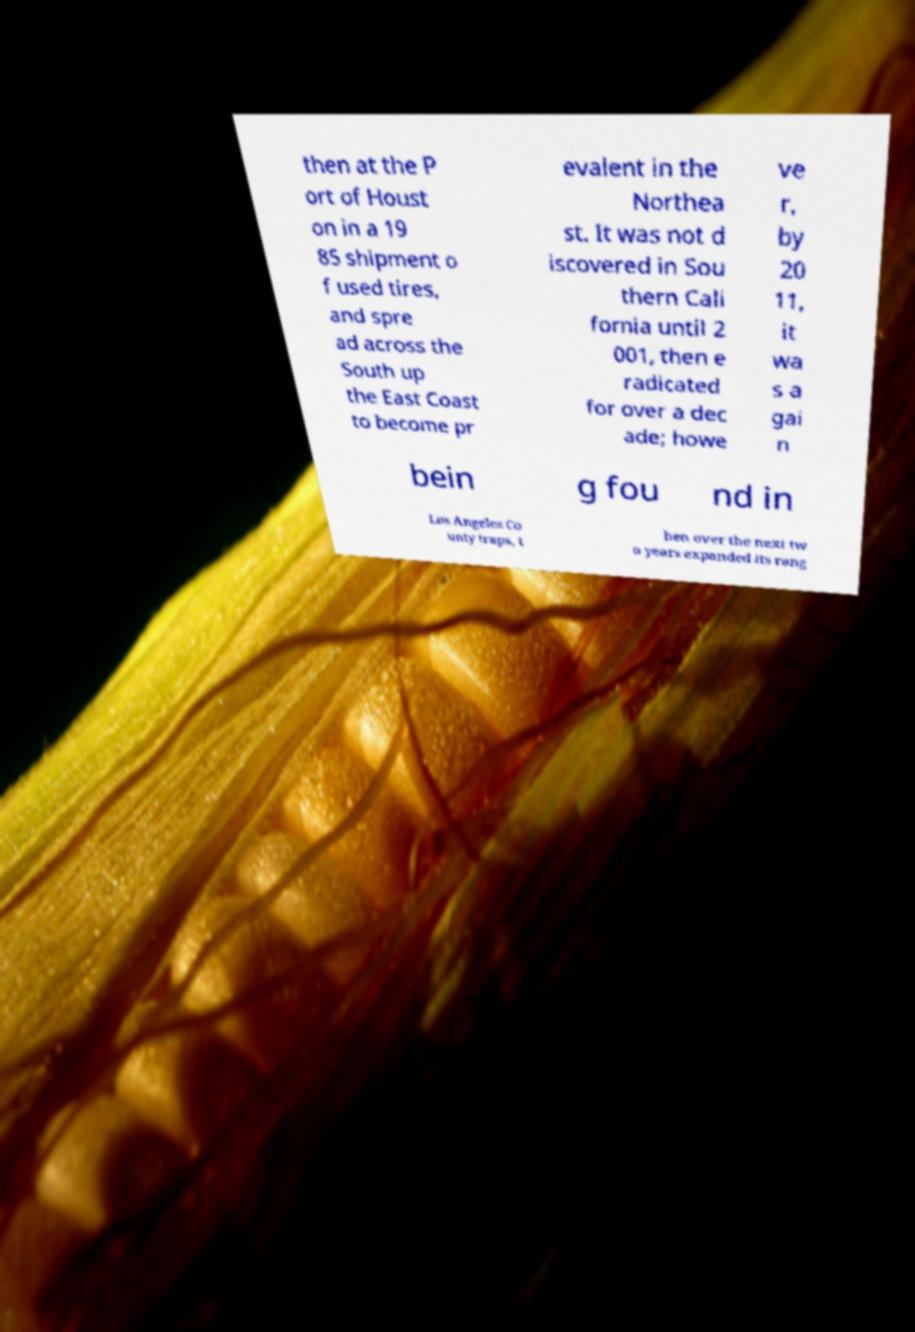I need the written content from this picture converted into text. Can you do that? then at the P ort of Houst on in a 19 85 shipment o f used tires, and spre ad across the South up the East Coast to become pr evalent in the Northea st. It was not d iscovered in Sou thern Cali fornia until 2 001, then e radicated for over a dec ade; howe ve r, by 20 11, it wa s a gai n bein g fou nd in Los Angeles Co unty traps, t hen over the next tw o years expanded its rang 